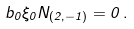<formula> <loc_0><loc_0><loc_500><loc_500>b _ { 0 } \xi _ { 0 } N _ { ( 2 , - 1 ) } = 0 \, .</formula> 